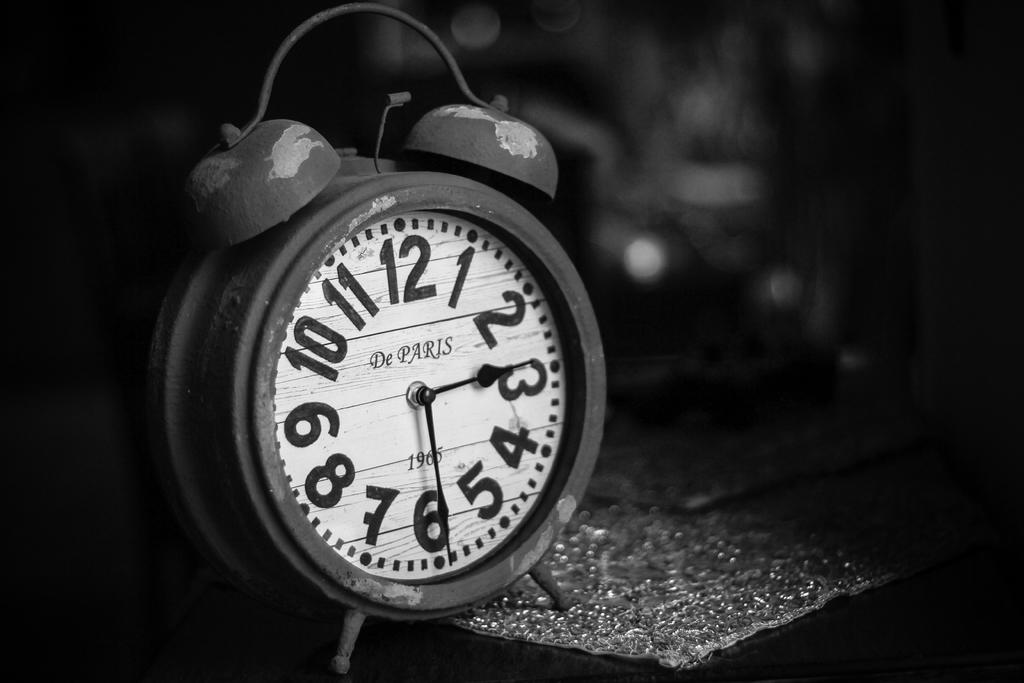Provide a one-sentence caption for the provided image. A 1965 alarm clock shows that it is 2:30. 